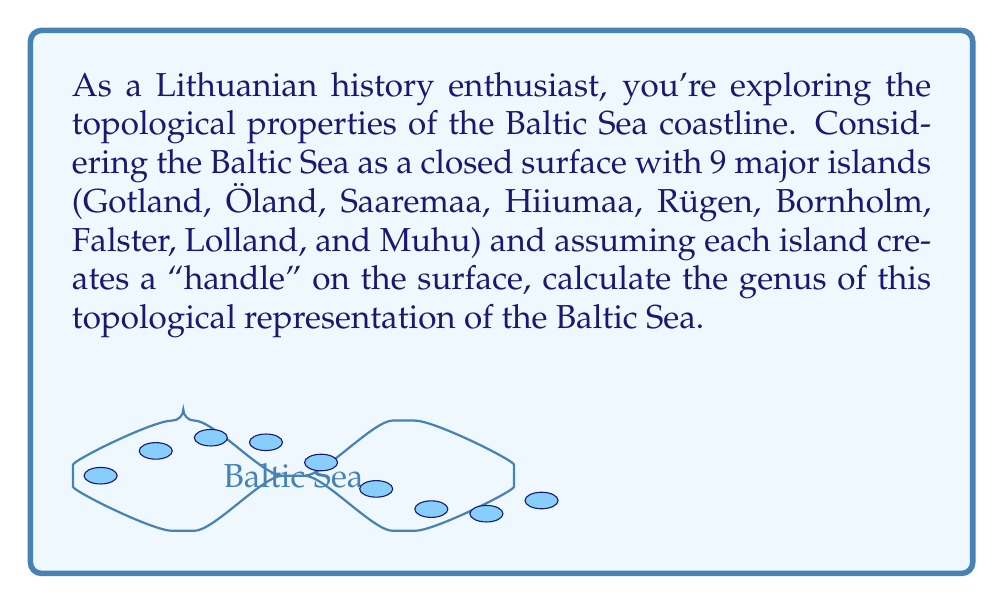Can you answer this question? To calculate the genus of a topological surface, we need to understand a few key concepts:

1. The genus of a surface is the number of "handles" or "holes" it has.
2. Each island in our representation creates a handle on the surface.

Given:
- The Baltic Sea is considered as a closed surface.
- There are 9 major islands, each creating a handle.

Step 1: Identify the base surface.
The Baltic Sea without islands would be topologically equivalent to a sphere, which has a genus of 0.

Step 2: Count the number of handles.
Each island adds one handle to the surface. We have 9 islands, so we add 9 handles.

Step 3: Calculate the genus.
The genus (g) is equal to the number of handles added to the base surface.

$$g = 0 + 9 = 9$$

Therefore, the genus of our topological representation of the Baltic Sea coastline is 9.

Note: In topology, this surface would be equivalent to a sphere with 9 handles, often denoted as $$\#_9(S^1 \times S^2)$$ or a surface of genus 9.
Answer: 9 